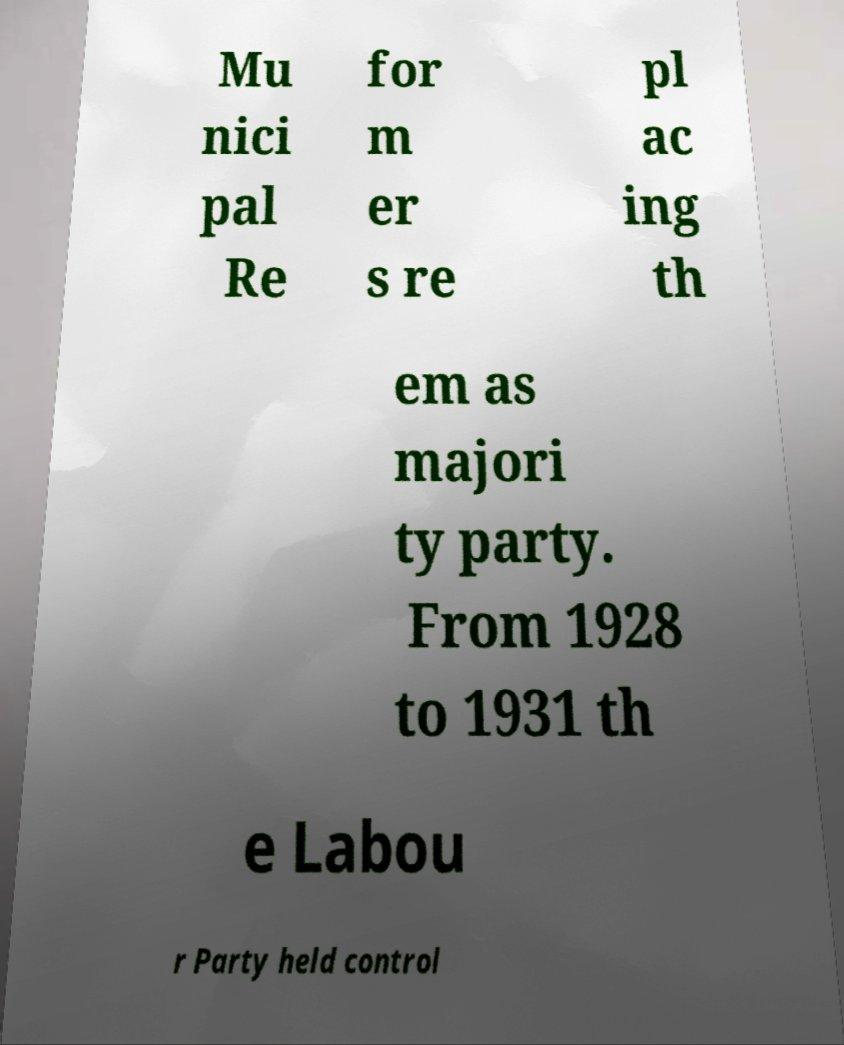I need the written content from this picture converted into text. Can you do that? Mu nici pal Re for m er s re pl ac ing th em as majori ty party. From 1928 to 1931 th e Labou r Party held control 